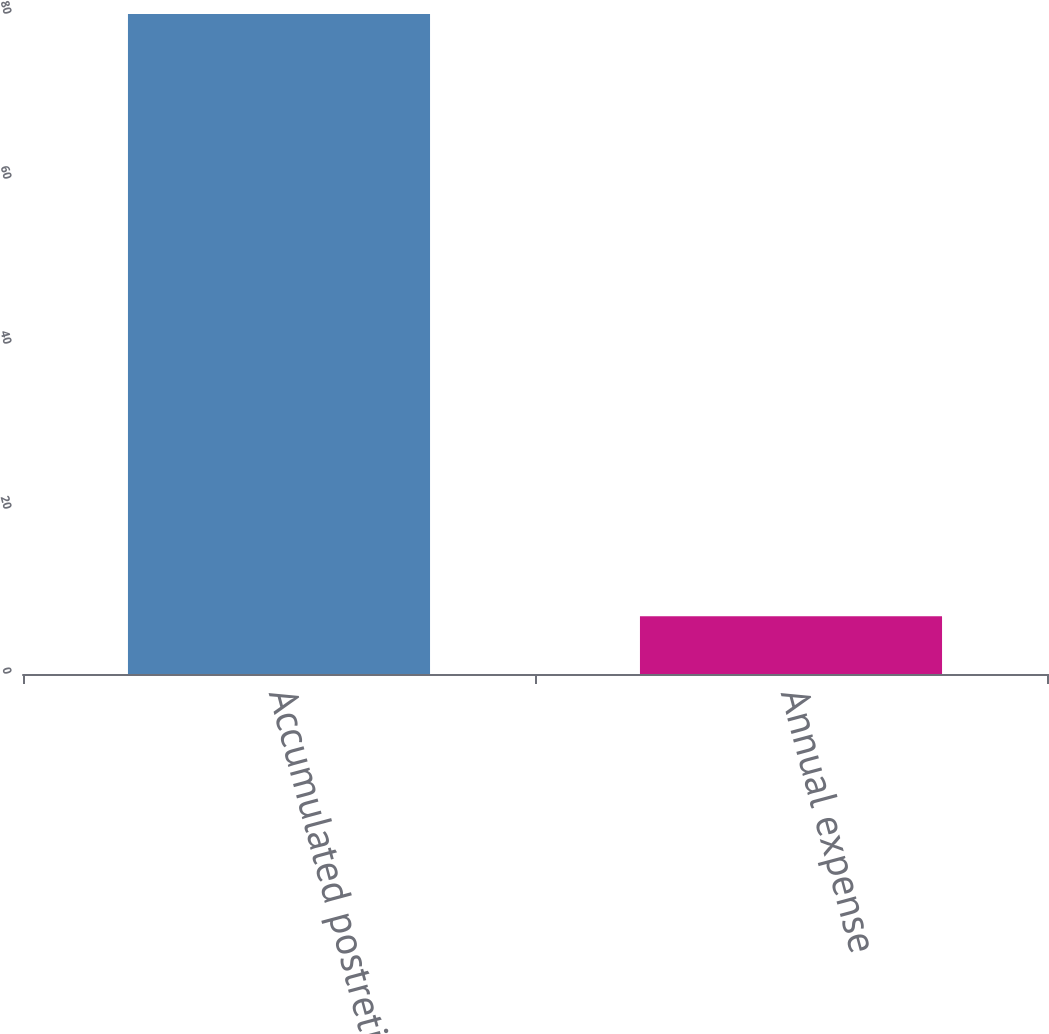Convert chart. <chart><loc_0><loc_0><loc_500><loc_500><bar_chart><fcel>Accumulated postretirement<fcel>Annual expense<nl><fcel>80<fcel>7<nl></chart> 